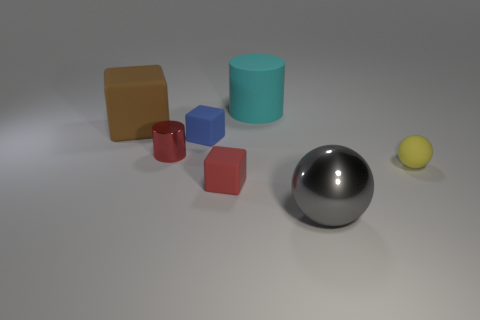The cylinder that is in front of the tiny blue rubber object is what color? red 